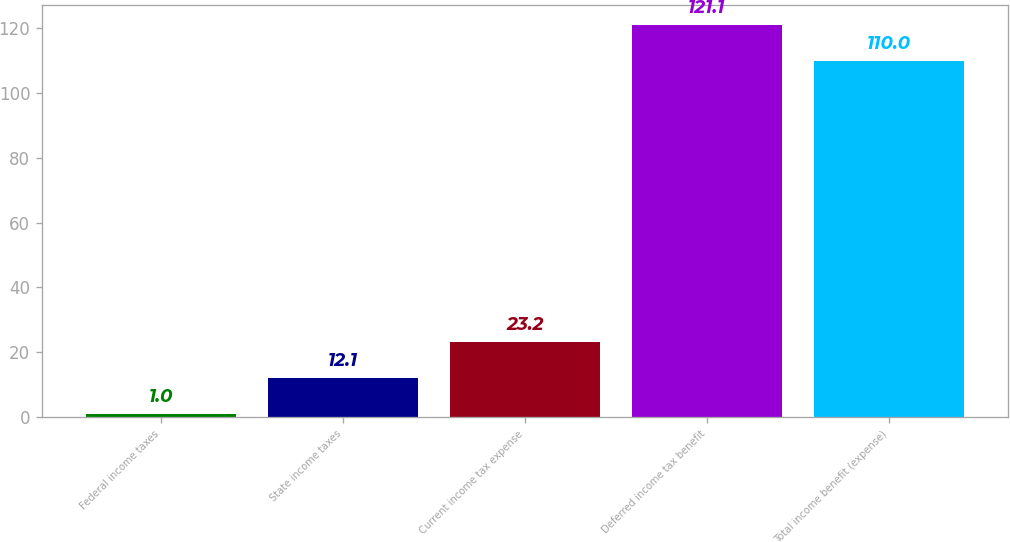<chart> <loc_0><loc_0><loc_500><loc_500><bar_chart><fcel>Federal income taxes<fcel>State income taxes<fcel>Current income tax expense<fcel>Deferred income tax benefit<fcel>Total income benefit (expense)<nl><fcel>1<fcel>12.1<fcel>23.2<fcel>121.1<fcel>110<nl></chart> 